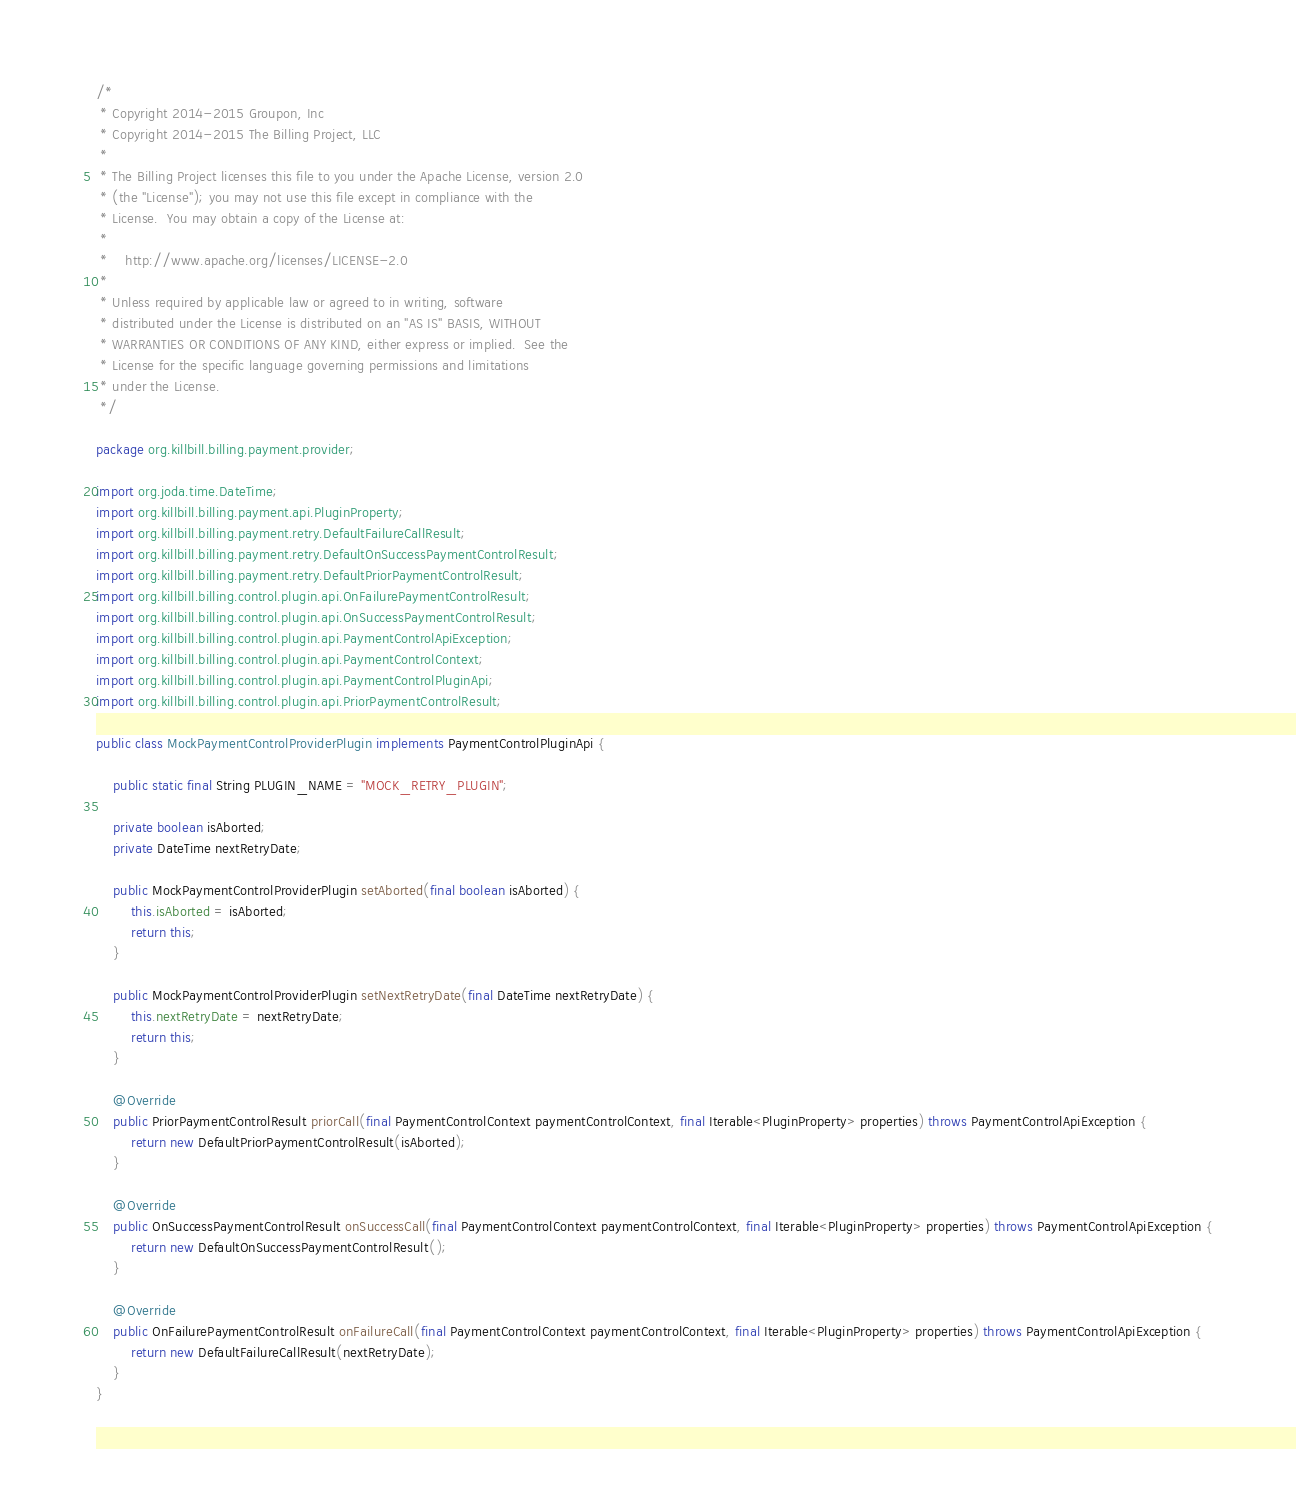<code> <loc_0><loc_0><loc_500><loc_500><_Java_>/*
 * Copyright 2014-2015 Groupon, Inc
 * Copyright 2014-2015 The Billing Project, LLC
 *
 * The Billing Project licenses this file to you under the Apache License, version 2.0
 * (the "License"); you may not use this file except in compliance with the
 * License.  You may obtain a copy of the License at:
 *
 *    http://www.apache.org/licenses/LICENSE-2.0
 *
 * Unless required by applicable law or agreed to in writing, software
 * distributed under the License is distributed on an "AS IS" BASIS, WITHOUT
 * WARRANTIES OR CONDITIONS OF ANY KIND, either express or implied.  See the
 * License for the specific language governing permissions and limitations
 * under the License.
 */

package org.killbill.billing.payment.provider;

import org.joda.time.DateTime;
import org.killbill.billing.payment.api.PluginProperty;
import org.killbill.billing.payment.retry.DefaultFailureCallResult;
import org.killbill.billing.payment.retry.DefaultOnSuccessPaymentControlResult;
import org.killbill.billing.payment.retry.DefaultPriorPaymentControlResult;
import org.killbill.billing.control.plugin.api.OnFailurePaymentControlResult;
import org.killbill.billing.control.plugin.api.OnSuccessPaymentControlResult;
import org.killbill.billing.control.plugin.api.PaymentControlApiException;
import org.killbill.billing.control.plugin.api.PaymentControlContext;
import org.killbill.billing.control.plugin.api.PaymentControlPluginApi;
import org.killbill.billing.control.plugin.api.PriorPaymentControlResult;

public class MockPaymentControlProviderPlugin implements PaymentControlPluginApi {

    public static final String PLUGIN_NAME = "MOCK_RETRY_PLUGIN";

    private boolean isAborted;
    private DateTime nextRetryDate;

    public MockPaymentControlProviderPlugin setAborted(final boolean isAborted) {
        this.isAborted = isAborted;
        return this;
    }

    public MockPaymentControlProviderPlugin setNextRetryDate(final DateTime nextRetryDate) {
        this.nextRetryDate = nextRetryDate;
        return this;
    }

    @Override
    public PriorPaymentControlResult priorCall(final PaymentControlContext paymentControlContext, final Iterable<PluginProperty> properties) throws PaymentControlApiException {
        return new DefaultPriorPaymentControlResult(isAborted);
    }

    @Override
    public OnSuccessPaymentControlResult onSuccessCall(final PaymentControlContext paymentControlContext, final Iterable<PluginProperty> properties) throws PaymentControlApiException {
        return new DefaultOnSuccessPaymentControlResult();
    }

    @Override
    public OnFailurePaymentControlResult onFailureCall(final PaymentControlContext paymentControlContext, final Iterable<PluginProperty> properties) throws PaymentControlApiException {
        return new DefaultFailureCallResult(nextRetryDate);
    }
}
</code> 